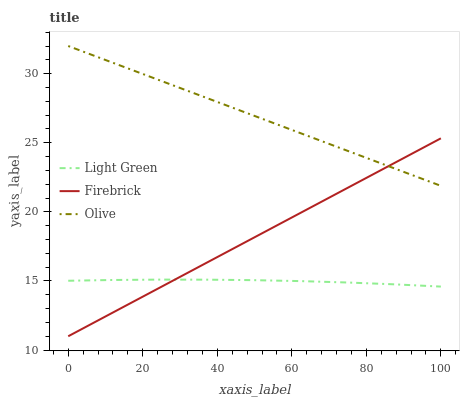Does Light Green have the minimum area under the curve?
Answer yes or no. Yes. Does Olive have the maximum area under the curve?
Answer yes or no. Yes. Does Firebrick have the minimum area under the curve?
Answer yes or no. No. Does Firebrick have the maximum area under the curve?
Answer yes or no. No. Is Firebrick the smoothest?
Answer yes or no. Yes. Is Light Green the roughest?
Answer yes or no. Yes. Is Light Green the smoothest?
Answer yes or no. No. Is Firebrick the roughest?
Answer yes or no. No. Does Light Green have the lowest value?
Answer yes or no. No. Does Olive have the highest value?
Answer yes or no. Yes. Does Firebrick have the highest value?
Answer yes or no. No. Is Light Green less than Olive?
Answer yes or no. Yes. Is Olive greater than Light Green?
Answer yes or no. Yes. Does Firebrick intersect Light Green?
Answer yes or no. Yes. Is Firebrick less than Light Green?
Answer yes or no. No. Is Firebrick greater than Light Green?
Answer yes or no. No. Does Light Green intersect Olive?
Answer yes or no. No. 